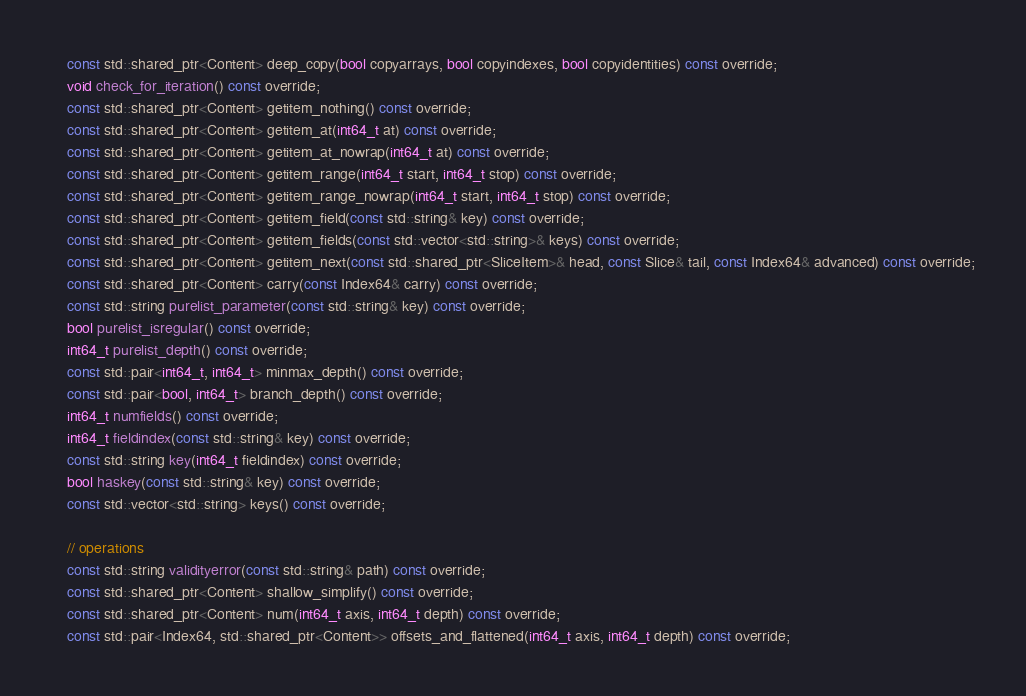Convert code to text. <code><loc_0><loc_0><loc_500><loc_500><_C_>    const std::shared_ptr<Content> deep_copy(bool copyarrays, bool copyindexes, bool copyidentities) const override;
    void check_for_iteration() const override;
    const std::shared_ptr<Content> getitem_nothing() const override;
    const std::shared_ptr<Content> getitem_at(int64_t at) const override;
    const std::shared_ptr<Content> getitem_at_nowrap(int64_t at) const override;
    const std::shared_ptr<Content> getitem_range(int64_t start, int64_t stop) const override;
    const std::shared_ptr<Content> getitem_range_nowrap(int64_t start, int64_t stop) const override;
    const std::shared_ptr<Content> getitem_field(const std::string& key) const override;
    const std::shared_ptr<Content> getitem_fields(const std::vector<std::string>& keys) const override;
    const std::shared_ptr<Content> getitem_next(const std::shared_ptr<SliceItem>& head, const Slice& tail, const Index64& advanced) const override;
    const std::shared_ptr<Content> carry(const Index64& carry) const override;
    const std::string purelist_parameter(const std::string& key) const override;
    bool purelist_isregular() const override;
    int64_t purelist_depth() const override;
    const std::pair<int64_t, int64_t> minmax_depth() const override;
    const std::pair<bool, int64_t> branch_depth() const override;
    int64_t numfields() const override;
    int64_t fieldindex(const std::string& key) const override;
    const std::string key(int64_t fieldindex) const override;
    bool haskey(const std::string& key) const override;
    const std::vector<std::string> keys() const override;

    // operations
    const std::string validityerror(const std::string& path) const override;
    const std::shared_ptr<Content> shallow_simplify() const override;
    const std::shared_ptr<Content> num(int64_t axis, int64_t depth) const override;
    const std::pair<Index64, std::shared_ptr<Content>> offsets_and_flattened(int64_t axis, int64_t depth) const override;</code> 